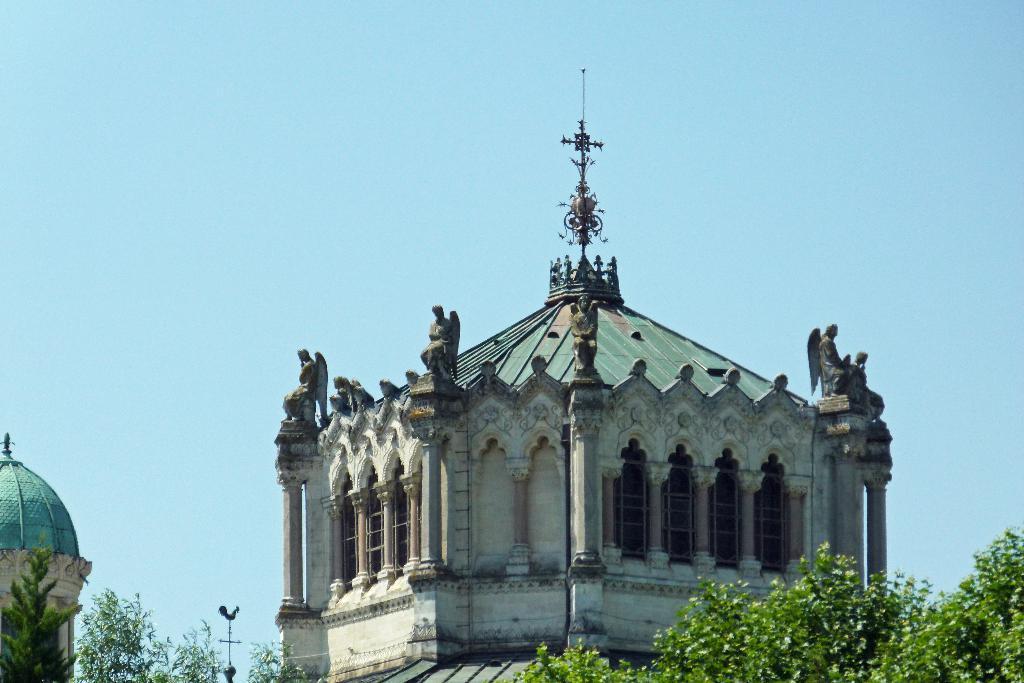Please provide a concise description of this image. In the image I can see building to which there some windows, statues and also I can see some trees. 